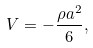<formula> <loc_0><loc_0><loc_500><loc_500>V = - \frac { \rho a ^ { 2 } } { 6 } ,</formula> 